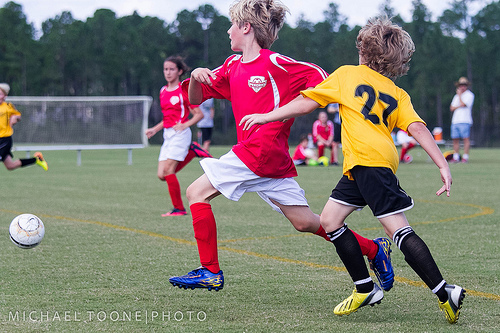<image>
Is there a kid on the ground? Yes. Looking at the image, I can see the kid is positioned on top of the ground, with the ground providing support. Is the net behind the ball? Yes. From this viewpoint, the net is positioned behind the ball, with the ball partially or fully occluding the net. 